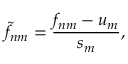<formula> <loc_0><loc_0><loc_500><loc_500>\tilde { f } _ { n m } = \frac { f _ { n m } - u _ { m } } { s _ { m } } ,</formula> 